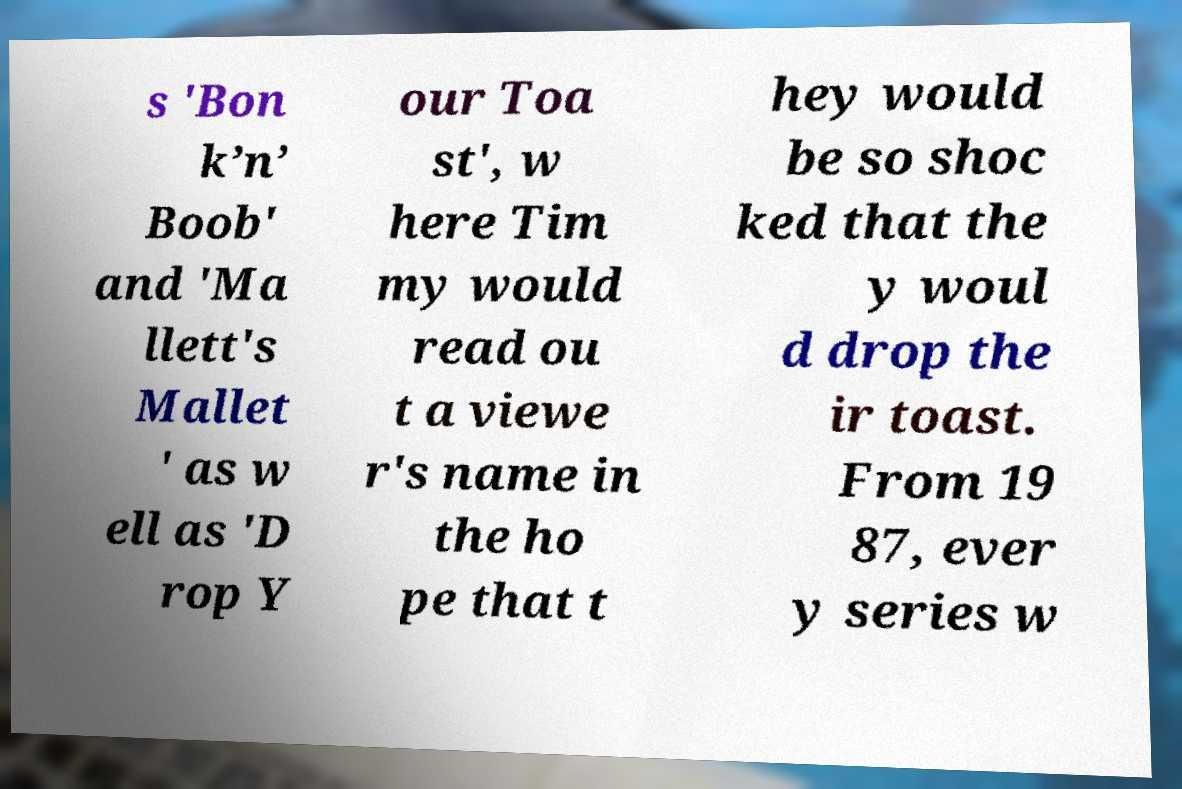There's text embedded in this image that I need extracted. Can you transcribe it verbatim? s 'Bon k’n’ Boob' and 'Ma llett's Mallet ' as w ell as 'D rop Y our Toa st', w here Tim my would read ou t a viewe r's name in the ho pe that t hey would be so shoc ked that the y woul d drop the ir toast. From 19 87, ever y series w 